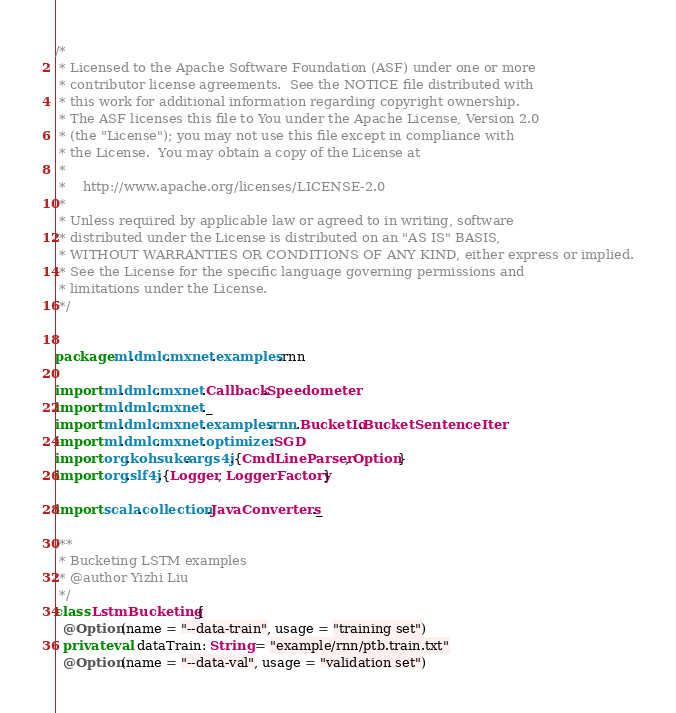<code> <loc_0><loc_0><loc_500><loc_500><_Scala_>/*
 * Licensed to the Apache Software Foundation (ASF) under one or more
 * contributor license agreements.  See the NOTICE file distributed with
 * this work for additional information regarding copyright ownership.
 * The ASF licenses this file to You under the Apache License, Version 2.0
 * (the "License"); you may not use this file except in compliance with
 * the License.  You may obtain a copy of the License at
 *
 *    http://www.apache.org/licenses/LICENSE-2.0
 *
 * Unless required by applicable law or agreed to in writing, software
 * distributed under the License is distributed on an "AS IS" BASIS,
 * WITHOUT WARRANTIES OR CONDITIONS OF ANY KIND, either express or implied.
 * See the License for the specific language governing permissions and
 * limitations under the License.
 */


package ml.dmlc.mxnet.examples.rnn

import ml.dmlc.mxnet.Callback.Speedometer
import ml.dmlc.mxnet._
import ml.dmlc.mxnet.examples.rnn.BucketIo.BucketSentenceIter
import ml.dmlc.mxnet.optimizer.SGD
import org.kohsuke.args4j.{CmdLineParser, Option}
import org.slf4j.{Logger, LoggerFactory}

import scala.collection.JavaConverters._

/**
 * Bucketing LSTM examples
 * @author Yizhi Liu
 */
class LstmBucketing {
  @Option(name = "--data-train", usage = "training set")
  private val dataTrain: String = "example/rnn/ptb.train.txt"
  @Option(name = "--data-val", usage = "validation set")</code> 